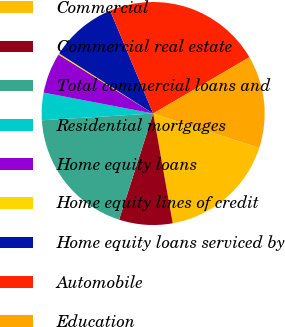<chart> <loc_0><loc_0><loc_500><loc_500><pie_chart><fcel>Commercial<fcel>Commercial real estate<fcel>Total commercial loans and<fcel>Residential mortgages<fcel>Home equity loans<fcel>Home equity lines of credit<fcel>Home equity loans serviced by<fcel>Automobile<fcel>Education<nl><fcel>17.2%<fcel>7.75%<fcel>19.09%<fcel>3.97%<fcel>5.86%<fcel>0.19%<fcel>9.64%<fcel>22.88%<fcel>13.42%<nl></chart> 